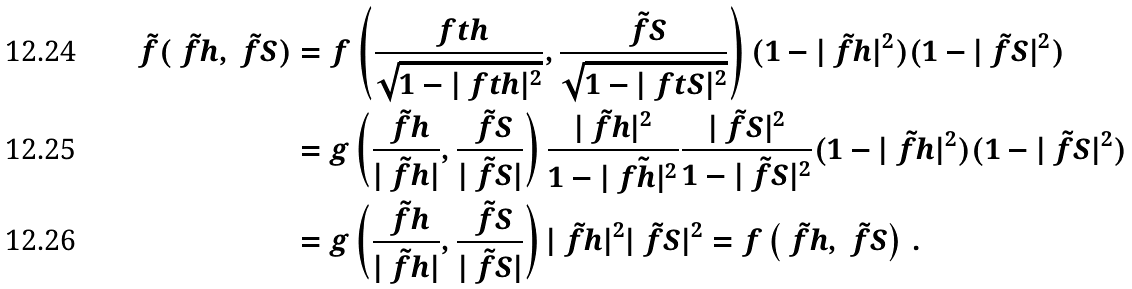<formula> <loc_0><loc_0><loc_500><loc_500>\tilde { f } ( \tilde { \ f h } , \tilde { \ f S } ) & = f \left ( \frac { \ f t h } { \sqrt { 1 - | \ f t h | ^ { 2 } } } , \frac { \tilde { \ f S } } { \sqrt { 1 - | \ f t S | ^ { 2 } } } \right ) ( 1 - | \tilde { \ f h } | ^ { 2 } ) ( 1 - | \tilde { \ f S } | ^ { 2 } ) \\ & = g \left ( \frac { \tilde { \ f h } } { | \tilde { \ f h } | } , \frac { \tilde { \ f S } } { | \tilde { \ f S } | } \right ) \frac { | \tilde { \ f h } | ^ { 2 } } { 1 - | \tilde { \ f h | ^ { 2 } } } \frac { | \tilde { \ f S } | ^ { 2 } } { 1 - | \tilde { \ f S } | ^ { 2 } } ( 1 - | \tilde { \ f h } | ^ { 2 } ) ( 1 - | \tilde { \ f S } | ^ { 2 } ) \\ & = g \left ( \frac { \tilde { \ f h } } { | \tilde { \ f h } | } , \frac { \tilde { \ f S } } { | \tilde { \ f S } | } \right ) | \tilde { \ f h } | ^ { 2 } | \tilde { \ f S } | ^ { 2 } = f \left ( \tilde { \ f h } , \tilde { \ f S } \right ) \, .</formula> 